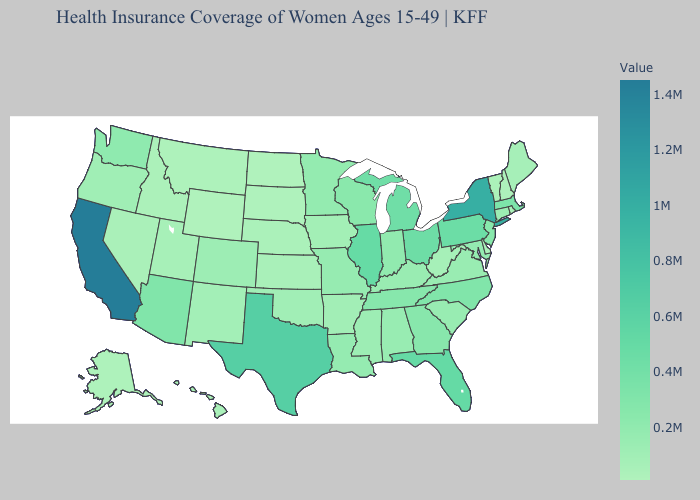Does California have the highest value in the USA?
Answer briefly. Yes. Among the states that border California , which have the lowest value?
Answer briefly. Nevada. Which states hav the highest value in the Northeast?
Concise answer only. New York. Does Rhode Island have the lowest value in the Northeast?
Write a very short answer. No. Which states have the lowest value in the South?
Be succinct. Delaware. 